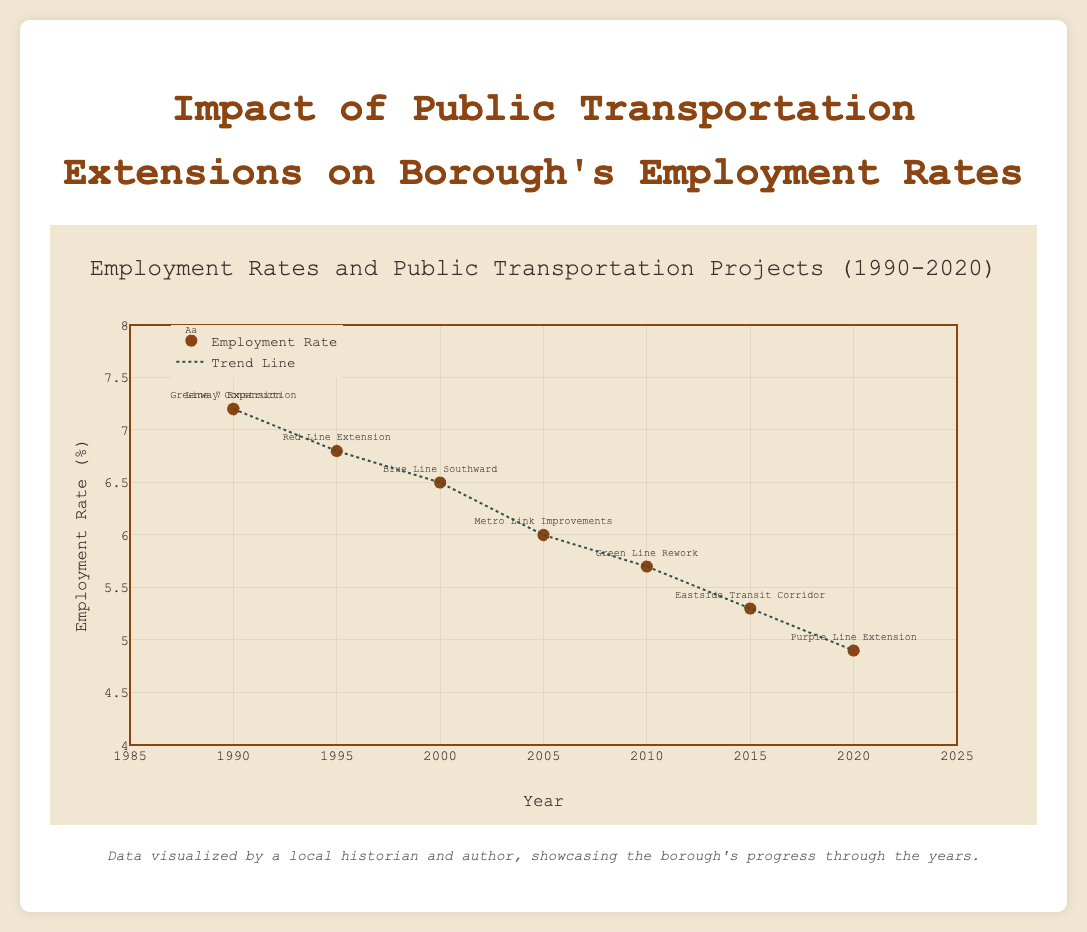What is the title of the figure? The title of the figure is located at the top and it summarizes the main topic of the plot.
Answer: Impact of Public Transportation Extensions on Borough's Employment Rates How many public transportation extension projects are represented in the figure? By counting the unique names of the extension projects listed in the text annotations of the scatter plot, we can determine the number of projects.
Answer: 8 What are the years covered in the figure? The x-axis represents the years, and by looking at the range and ticks on this axis, we can identify the span of years.
Answer: 1990-2020 What is the overall trend in employment rates from 1990 to 2020? The trend line gives an indication of the overall pattern in employment rates over time. By observing the downward slope, we can infer the trend.
Answer: Decreasing Which year shows the lowest employment rate, and what is the rate? The lowest point on the scatter plot indicates the year with the lowest employment rate. By looking at the y-axis value and the corresponding x-axis label, we can identify the year and rate.
Answer: 2020, 4.9% What's the difference in employment rates between the year 1990 and the year 2020? By identifying the employment rates for 1990 and 2020 from the scatter plot and subtracting the latter from the former, we can find the difference.
Answer: 2.3% Which extension project corresponds to an employment rate of 6.0% and in which year was it completed? By matching the text annotation with the given employment rate, we can identify the corresponding project and year.
Answer: Metro Link Improvements, 2005 How does the employment rate in 2000 compare to the employment rate in 2010? By looking at the y-axis values for the years 2000 and 2010 on the scatter plot, we can compare the employment rates directly.
Answer: Higher in 2000 What is the average employment rate from 1990 to 2020? Sum the employment rates for all represented years and divide by the number of data points to calculate the average.
Answer: 6.2% What might be a reason for the overall decreasing trend in employment rates from 1990 to 2020? Considering the figure and general historical context, the completion of several public transportation projects could lead to better job accessibility and economic growth, thus lowering unemployment rates over time.
Answer: Improved transportation infrastructure 